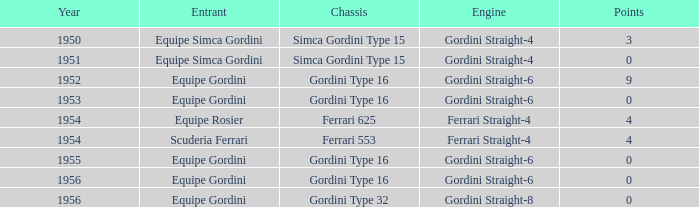Which structure contains less than 9 points by equipe rosier? Ferrari 625. 